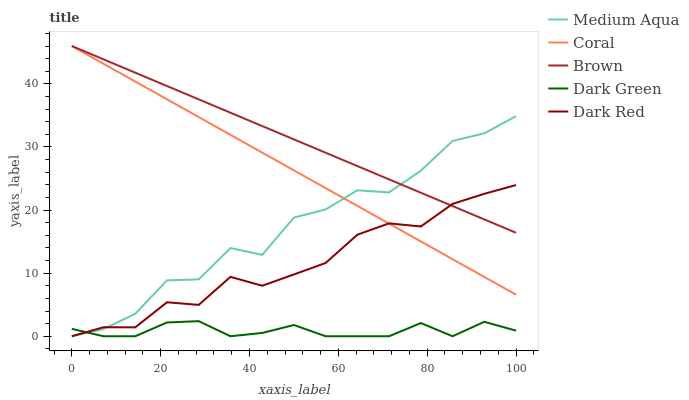Does Dark Green have the minimum area under the curve?
Answer yes or no. Yes. Does Brown have the maximum area under the curve?
Answer yes or no. Yes. Does Coral have the minimum area under the curve?
Answer yes or no. No. Does Coral have the maximum area under the curve?
Answer yes or no. No. Is Brown the smoothest?
Answer yes or no. Yes. Is Medium Aqua the roughest?
Answer yes or no. Yes. Is Coral the smoothest?
Answer yes or no. No. Is Coral the roughest?
Answer yes or no. No. Does Dark Red have the lowest value?
Answer yes or no. Yes. Does Coral have the lowest value?
Answer yes or no. No. Does Coral have the highest value?
Answer yes or no. Yes. Does Dark Red have the highest value?
Answer yes or no. No. Is Dark Green less than Coral?
Answer yes or no. Yes. Is Brown greater than Dark Green?
Answer yes or no. Yes. Does Coral intersect Dark Red?
Answer yes or no. Yes. Is Coral less than Dark Red?
Answer yes or no. No. Is Coral greater than Dark Red?
Answer yes or no. No. Does Dark Green intersect Coral?
Answer yes or no. No. 